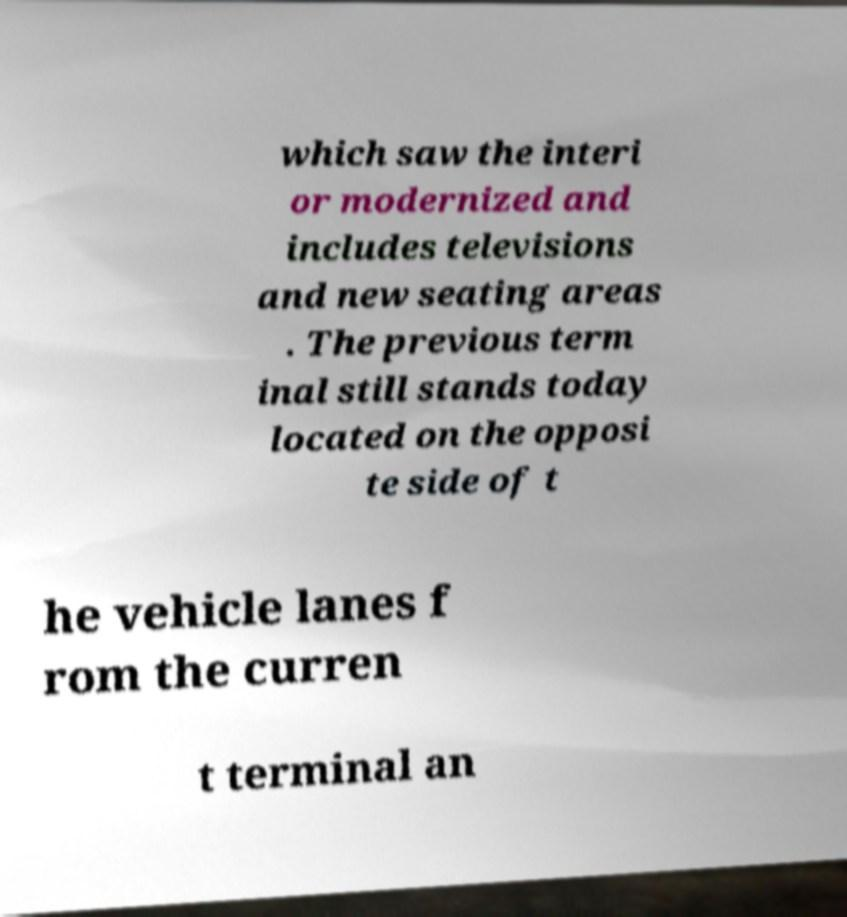Please identify and transcribe the text found in this image. which saw the interi or modernized and includes televisions and new seating areas . The previous term inal still stands today located on the opposi te side of t he vehicle lanes f rom the curren t terminal an 